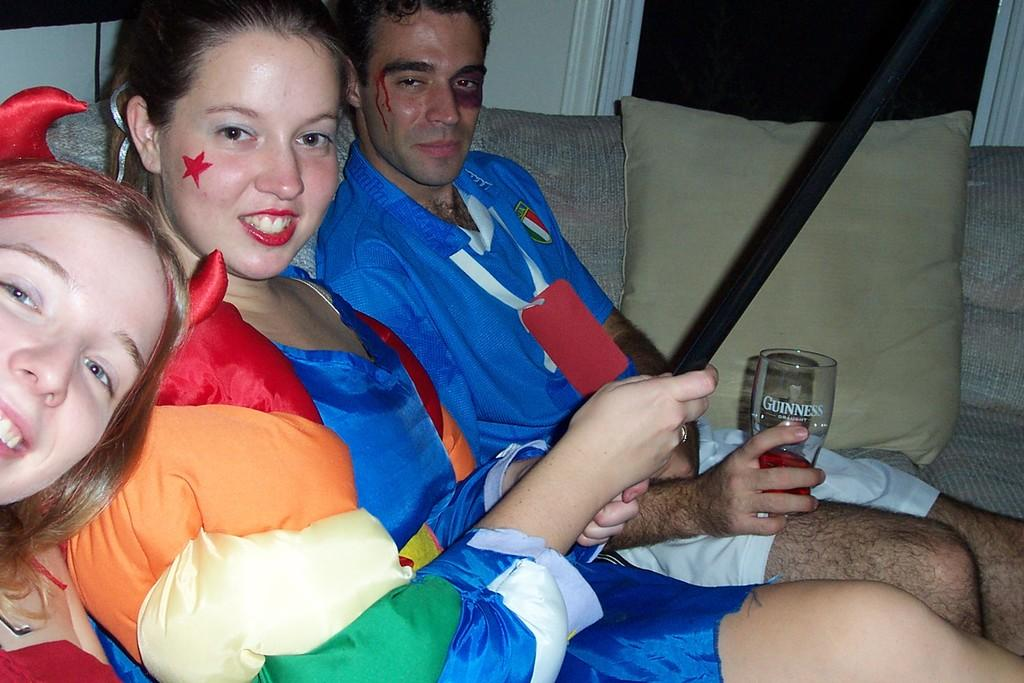<image>
Present a compact description of the photo's key features. A group of sports fans, one holding a glass of Guinness Draught. 